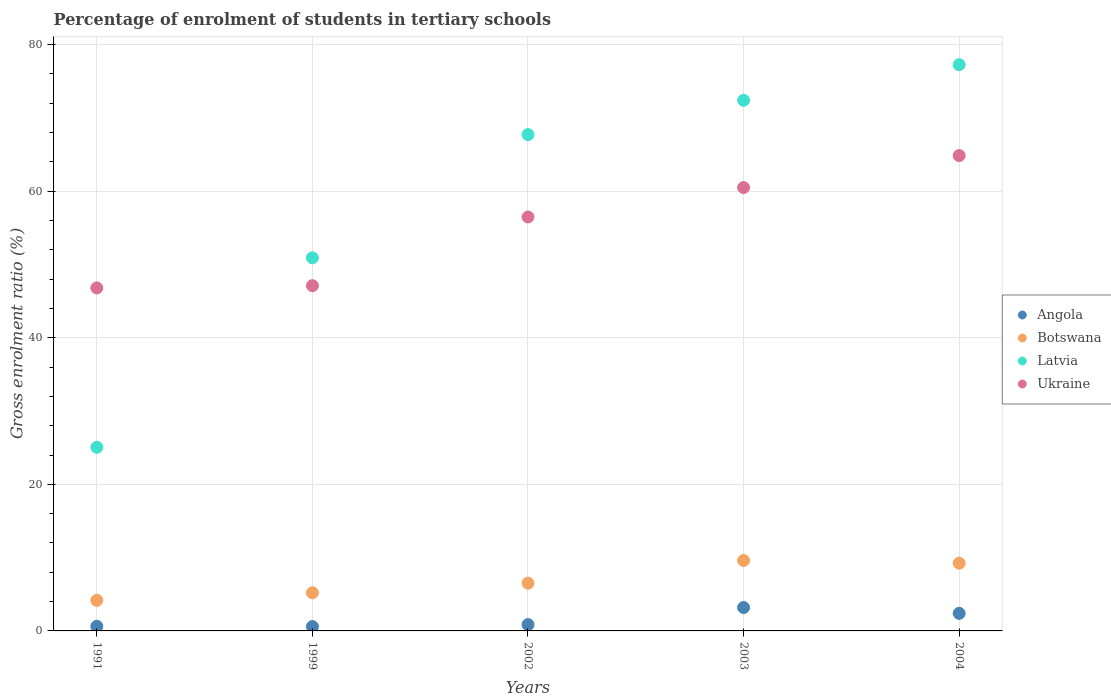What is the percentage of students enrolled in tertiary schools in Ukraine in 1991?
Make the answer very short. 46.8. Across all years, what is the maximum percentage of students enrolled in tertiary schools in Ukraine?
Make the answer very short. 64.86. Across all years, what is the minimum percentage of students enrolled in tertiary schools in Angola?
Keep it short and to the point. 0.6. In which year was the percentage of students enrolled in tertiary schools in Ukraine maximum?
Make the answer very short. 2004. In which year was the percentage of students enrolled in tertiary schools in Botswana minimum?
Keep it short and to the point. 1991. What is the total percentage of students enrolled in tertiary schools in Ukraine in the graph?
Offer a terse response. 275.73. What is the difference between the percentage of students enrolled in tertiary schools in Botswana in 2002 and that in 2004?
Make the answer very short. -2.72. What is the difference between the percentage of students enrolled in tertiary schools in Angola in 2004 and the percentage of students enrolled in tertiary schools in Latvia in 2002?
Offer a terse response. -65.32. What is the average percentage of students enrolled in tertiary schools in Ukraine per year?
Ensure brevity in your answer.  55.15. In the year 2004, what is the difference between the percentage of students enrolled in tertiary schools in Ukraine and percentage of students enrolled in tertiary schools in Angola?
Your response must be concise. 62.46. What is the ratio of the percentage of students enrolled in tertiary schools in Ukraine in 1991 to that in 2004?
Your response must be concise. 0.72. Is the percentage of students enrolled in tertiary schools in Angola in 1991 less than that in 2003?
Your answer should be compact. Yes. Is the difference between the percentage of students enrolled in tertiary schools in Ukraine in 1991 and 2004 greater than the difference between the percentage of students enrolled in tertiary schools in Angola in 1991 and 2004?
Your answer should be compact. No. What is the difference between the highest and the second highest percentage of students enrolled in tertiary schools in Angola?
Your answer should be very brief. 0.8. What is the difference between the highest and the lowest percentage of students enrolled in tertiary schools in Angola?
Make the answer very short. 2.6. Is it the case that in every year, the sum of the percentage of students enrolled in tertiary schools in Ukraine and percentage of students enrolled in tertiary schools in Latvia  is greater than the percentage of students enrolled in tertiary schools in Angola?
Provide a short and direct response. Yes. Does the percentage of students enrolled in tertiary schools in Botswana monotonically increase over the years?
Offer a terse response. No. Is the percentage of students enrolled in tertiary schools in Angola strictly greater than the percentage of students enrolled in tertiary schools in Latvia over the years?
Your answer should be compact. No. Is the percentage of students enrolled in tertiary schools in Ukraine strictly less than the percentage of students enrolled in tertiary schools in Angola over the years?
Provide a succinct answer. No. How many dotlines are there?
Your answer should be compact. 4. Are the values on the major ticks of Y-axis written in scientific E-notation?
Your response must be concise. No. Does the graph contain any zero values?
Offer a terse response. No. Does the graph contain grids?
Your answer should be very brief. Yes. Where does the legend appear in the graph?
Provide a succinct answer. Center right. What is the title of the graph?
Offer a terse response. Percentage of enrolment of students in tertiary schools. Does "Sub-Saharan Africa (all income levels)" appear as one of the legend labels in the graph?
Provide a short and direct response. No. What is the Gross enrolment ratio (%) of Angola in 1991?
Ensure brevity in your answer.  0.63. What is the Gross enrolment ratio (%) of Botswana in 1991?
Give a very brief answer. 4.17. What is the Gross enrolment ratio (%) in Latvia in 1991?
Offer a very short reply. 25.06. What is the Gross enrolment ratio (%) in Ukraine in 1991?
Ensure brevity in your answer.  46.8. What is the Gross enrolment ratio (%) of Angola in 1999?
Provide a short and direct response. 0.6. What is the Gross enrolment ratio (%) in Botswana in 1999?
Offer a very short reply. 5.21. What is the Gross enrolment ratio (%) in Latvia in 1999?
Give a very brief answer. 50.91. What is the Gross enrolment ratio (%) of Ukraine in 1999?
Offer a very short reply. 47.1. What is the Gross enrolment ratio (%) in Angola in 2002?
Your answer should be compact. 0.86. What is the Gross enrolment ratio (%) of Botswana in 2002?
Make the answer very short. 6.52. What is the Gross enrolment ratio (%) in Latvia in 2002?
Make the answer very short. 67.72. What is the Gross enrolment ratio (%) of Ukraine in 2002?
Provide a succinct answer. 56.48. What is the Gross enrolment ratio (%) of Angola in 2003?
Your answer should be very brief. 3.19. What is the Gross enrolment ratio (%) of Botswana in 2003?
Your answer should be compact. 9.61. What is the Gross enrolment ratio (%) of Latvia in 2003?
Ensure brevity in your answer.  72.4. What is the Gross enrolment ratio (%) of Ukraine in 2003?
Give a very brief answer. 60.49. What is the Gross enrolment ratio (%) of Angola in 2004?
Your answer should be very brief. 2.4. What is the Gross enrolment ratio (%) in Botswana in 2004?
Keep it short and to the point. 9.24. What is the Gross enrolment ratio (%) of Latvia in 2004?
Offer a terse response. 77.26. What is the Gross enrolment ratio (%) in Ukraine in 2004?
Provide a short and direct response. 64.86. Across all years, what is the maximum Gross enrolment ratio (%) in Angola?
Your response must be concise. 3.19. Across all years, what is the maximum Gross enrolment ratio (%) in Botswana?
Provide a short and direct response. 9.61. Across all years, what is the maximum Gross enrolment ratio (%) in Latvia?
Offer a terse response. 77.26. Across all years, what is the maximum Gross enrolment ratio (%) of Ukraine?
Provide a succinct answer. 64.86. Across all years, what is the minimum Gross enrolment ratio (%) of Angola?
Ensure brevity in your answer.  0.6. Across all years, what is the minimum Gross enrolment ratio (%) of Botswana?
Ensure brevity in your answer.  4.17. Across all years, what is the minimum Gross enrolment ratio (%) in Latvia?
Your answer should be compact. 25.06. Across all years, what is the minimum Gross enrolment ratio (%) of Ukraine?
Give a very brief answer. 46.8. What is the total Gross enrolment ratio (%) of Angola in the graph?
Your response must be concise. 7.67. What is the total Gross enrolment ratio (%) of Botswana in the graph?
Offer a very short reply. 34.75. What is the total Gross enrolment ratio (%) of Latvia in the graph?
Provide a short and direct response. 293.35. What is the total Gross enrolment ratio (%) in Ukraine in the graph?
Offer a very short reply. 275.73. What is the difference between the Gross enrolment ratio (%) in Angola in 1991 and that in 1999?
Ensure brevity in your answer.  0.03. What is the difference between the Gross enrolment ratio (%) of Botswana in 1991 and that in 1999?
Make the answer very short. -1.03. What is the difference between the Gross enrolment ratio (%) of Latvia in 1991 and that in 1999?
Keep it short and to the point. -25.85. What is the difference between the Gross enrolment ratio (%) in Ukraine in 1991 and that in 1999?
Your response must be concise. -0.3. What is the difference between the Gross enrolment ratio (%) in Angola in 1991 and that in 2002?
Give a very brief answer. -0.24. What is the difference between the Gross enrolment ratio (%) of Botswana in 1991 and that in 2002?
Your answer should be very brief. -2.35. What is the difference between the Gross enrolment ratio (%) of Latvia in 1991 and that in 2002?
Your answer should be very brief. -42.66. What is the difference between the Gross enrolment ratio (%) in Ukraine in 1991 and that in 2002?
Give a very brief answer. -9.68. What is the difference between the Gross enrolment ratio (%) of Angola in 1991 and that in 2003?
Your answer should be compact. -2.57. What is the difference between the Gross enrolment ratio (%) of Botswana in 1991 and that in 2003?
Provide a succinct answer. -5.44. What is the difference between the Gross enrolment ratio (%) of Latvia in 1991 and that in 2003?
Provide a short and direct response. -47.34. What is the difference between the Gross enrolment ratio (%) in Ukraine in 1991 and that in 2003?
Make the answer very short. -13.69. What is the difference between the Gross enrolment ratio (%) in Angola in 1991 and that in 2004?
Provide a succinct answer. -1.77. What is the difference between the Gross enrolment ratio (%) in Botswana in 1991 and that in 2004?
Make the answer very short. -5.07. What is the difference between the Gross enrolment ratio (%) of Latvia in 1991 and that in 2004?
Offer a terse response. -52.2. What is the difference between the Gross enrolment ratio (%) of Ukraine in 1991 and that in 2004?
Keep it short and to the point. -18.06. What is the difference between the Gross enrolment ratio (%) in Angola in 1999 and that in 2002?
Your answer should be compact. -0.27. What is the difference between the Gross enrolment ratio (%) in Botswana in 1999 and that in 2002?
Your answer should be compact. -1.31. What is the difference between the Gross enrolment ratio (%) in Latvia in 1999 and that in 2002?
Give a very brief answer. -16.81. What is the difference between the Gross enrolment ratio (%) in Ukraine in 1999 and that in 2002?
Provide a succinct answer. -9.38. What is the difference between the Gross enrolment ratio (%) in Angola in 1999 and that in 2003?
Your answer should be very brief. -2.6. What is the difference between the Gross enrolment ratio (%) in Botswana in 1999 and that in 2003?
Keep it short and to the point. -4.41. What is the difference between the Gross enrolment ratio (%) of Latvia in 1999 and that in 2003?
Make the answer very short. -21.49. What is the difference between the Gross enrolment ratio (%) of Ukraine in 1999 and that in 2003?
Your answer should be very brief. -13.39. What is the difference between the Gross enrolment ratio (%) of Angola in 1999 and that in 2004?
Provide a short and direct response. -1.8. What is the difference between the Gross enrolment ratio (%) of Botswana in 1999 and that in 2004?
Keep it short and to the point. -4.04. What is the difference between the Gross enrolment ratio (%) of Latvia in 1999 and that in 2004?
Give a very brief answer. -26.35. What is the difference between the Gross enrolment ratio (%) of Ukraine in 1999 and that in 2004?
Ensure brevity in your answer.  -17.75. What is the difference between the Gross enrolment ratio (%) in Angola in 2002 and that in 2003?
Your answer should be compact. -2.33. What is the difference between the Gross enrolment ratio (%) in Botswana in 2002 and that in 2003?
Your answer should be compact. -3.09. What is the difference between the Gross enrolment ratio (%) of Latvia in 2002 and that in 2003?
Keep it short and to the point. -4.68. What is the difference between the Gross enrolment ratio (%) in Ukraine in 2002 and that in 2003?
Provide a succinct answer. -4.01. What is the difference between the Gross enrolment ratio (%) in Angola in 2002 and that in 2004?
Your answer should be compact. -1.53. What is the difference between the Gross enrolment ratio (%) in Botswana in 2002 and that in 2004?
Offer a very short reply. -2.72. What is the difference between the Gross enrolment ratio (%) of Latvia in 2002 and that in 2004?
Ensure brevity in your answer.  -9.54. What is the difference between the Gross enrolment ratio (%) of Ukraine in 2002 and that in 2004?
Provide a short and direct response. -8.38. What is the difference between the Gross enrolment ratio (%) in Angola in 2003 and that in 2004?
Offer a terse response. 0.8. What is the difference between the Gross enrolment ratio (%) of Botswana in 2003 and that in 2004?
Make the answer very short. 0.37. What is the difference between the Gross enrolment ratio (%) of Latvia in 2003 and that in 2004?
Give a very brief answer. -4.86. What is the difference between the Gross enrolment ratio (%) of Ukraine in 2003 and that in 2004?
Your response must be concise. -4.36. What is the difference between the Gross enrolment ratio (%) of Angola in 1991 and the Gross enrolment ratio (%) of Botswana in 1999?
Keep it short and to the point. -4.58. What is the difference between the Gross enrolment ratio (%) of Angola in 1991 and the Gross enrolment ratio (%) of Latvia in 1999?
Make the answer very short. -50.28. What is the difference between the Gross enrolment ratio (%) in Angola in 1991 and the Gross enrolment ratio (%) in Ukraine in 1999?
Give a very brief answer. -46.48. What is the difference between the Gross enrolment ratio (%) in Botswana in 1991 and the Gross enrolment ratio (%) in Latvia in 1999?
Your response must be concise. -46.74. What is the difference between the Gross enrolment ratio (%) in Botswana in 1991 and the Gross enrolment ratio (%) in Ukraine in 1999?
Provide a succinct answer. -42.93. What is the difference between the Gross enrolment ratio (%) in Latvia in 1991 and the Gross enrolment ratio (%) in Ukraine in 1999?
Your response must be concise. -22.05. What is the difference between the Gross enrolment ratio (%) of Angola in 1991 and the Gross enrolment ratio (%) of Botswana in 2002?
Keep it short and to the point. -5.89. What is the difference between the Gross enrolment ratio (%) of Angola in 1991 and the Gross enrolment ratio (%) of Latvia in 2002?
Make the answer very short. -67.1. What is the difference between the Gross enrolment ratio (%) in Angola in 1991 and the Gross enrolment ratio (%) in Ukraine in 2002?
Give a very brief answer. -55.85. What is the difference between the Gross enrolment ratio (%) of Botswana in 1991 and the Gross enrolment ratio (%) of Latvia in 2002?
Offer a terse response. -63.55. What is the difference between the Gross enrolment ratio (%) of Botswana in 1991 and the Gross enrolment ratio (%) of Ukraine in 2002?
Keep it short and to the point. -52.31. What is the difference between the Gross enrolment ratio (%) in Latvia in 1991 and the Gross enrolment ratio (%) in Ukraine in 2002?
Give a very brief answer. -31.42. What is the difference between the Gross enrolment ratio (%) of Angola in 1991 and the Gross enrolment ratio (%) of Botswana in 2003?
Offer a terse response. -8.99. What is the difference between the Gross enrolment ratio (%) of Angola in 1991 and the Gross enrolment ratio (%) of Latvia in 2003?
Ensure brevity in your answer.  -71.78. What is the difference between the Gross enrolment ratio (%) of Angola in 1991 and the Gross enrolment ratio (%) of Ukraine in 2003?
Keep it short and to the point. -59.87. What is the difference between the Gross enrolment ratio (%) of Botswana in 1991 and the Gross enrolment ratio (%) of Latvia in 2003?
Your response must be concise. -68.23. What is the difference between the Gross enrolment ratio (%) of Botswana in 1991 and the Gross enrolment ratio (%) of Ukraine in 2003?
Offer a terse response. -56.32. What is the difference between the Gross enrolment ratio (%) in Latvia in 1991 and the Gross enrolment ratio (%) in Ukraine in 2003?
Provide a short and direct response. -35.44. What is the difference between the Gross enrolment ratio (%) in Angola in 1991 and the Gross enrolment ratio (%) in Botswana in 2004?
Give a very brief answer. -8.62. What is the difference between the Gross enrolment ratio (%) in Angola in 1991 and the Gross enrolment ratio (%) in Latvia in 2004?
Provide a short and direct response. -76.63. What is the difference between the Gross enrolment ratio (%) in Angola in 1991 and the Gross enrolment ratio (%) in Ukraine in 2004?
Keep it short and to the point. -64.23. What is the difference between the Gross enrolment ratio (%) of Botswana in 1991 and the Gross enrolment ratio (%) of Latvia in 2004?
Your answer should be very brief. -73.09. What is the difference between the Gross enrolment ratio (%) in Botswana in 1991 and the Gross enrolment ratio (%) in Ukraine in 2004?
Provide a short and direct response. -60.69. What is the difference between the Gross enrolment ratio (%) of Latvia in 1991 and the Gross enrolment ratio (%) of Ukraine in 2004?
Provide a short and direct response. -39.8. What is the difference between the Gross enrolment ratio (%) in Angola in 1999 and the Gross enrolment ratio (%) in Botswana in 2002?
Offer a terse response. -5.92. What is the difference between the Gross enrolment ratio (%) of Angola in 1999 and the Gross enrolment ratio (%) of Latvia in 2002?
Give a very brief answer. -67.13. What is the difference between the Gross enrolment ratio (%) of Angola in 1999 and the Gross enrolment ratio (%) of Ukraine in 2002?
Provide a short and direct response. -55.88. What is the difference between the Gross enrolment ratio (%) in Botswana in 1999 and the Gross enrolment ratio (%) in Latvia in 2002?
Offer a terse response. -62.52. What is the difference between the Gross enrolment ratio (%) of Botswana in 1999 and the Gross enrolment ratio (%) of Ukraine in 2002?
Make the answer very short. -51.27. What is the difference between the Gross enrolment ratio (%) in Latvia in 1999 and the Gross enrolment ratio (%) in Ukraine in 2002?
Your response must be concise. -5.57. What is the difference between the Gross enrolment ratio (%) of Angola in 1999 and the Gross enrolment ratio (%) of Botswana in 2003?
Your response must be concise. -9.02. What is the difference between the Gross enrolment ratio (%) of Angola in 1999 and the Gross enrolment ratio (%) of Latvia in 2003?
Provide a succinct answer. -71.81. What is the difference between the Gross enrolment ratio (%) in Angola in 1999 and the Gross enrolment ratio (%) in Ukraine in 2003?
Give a very brief answer. -59.9. What is the difference between the Gross enrolment ratio (%) of Botswana in 1999 and the Gross enrolment ratio (%) of Latvia in 2003?
Your answer should be compact. -67.2. What is the difference between the Gross enrolment ratio (%) in Botswana in 1999 and the Gross enrolment ratio (%) in Ukraine in 2003?
Offer a very short reply. -55.29. What is the difference between the Gross enrolment ratio (%) in Latvia in 1999 and the Gross enrolment ratio (%) in Ukraine in 2003?
Your answer should be very brief. -9.59. What is the difference between the Gross enrolment ratio (%) of Angola in 1999 and the Gross enrolment ratio (%) of Botswana in 2004?
Give a very brief answer. -8.65. What is the difference between the Gross enrolment ratio (%) of Angola in 1999 and the Gross enrolment ratio (%) of Latvia in 2004?
Offer a terse response. -76.66. What is the difference between the Gross enrolment ratio (%) in Angola in 1999 and the Gross enrolment ratio (%) in Ukraine in 2004?
Your answer should be compact. -64.26. What is the difference between the Gross enrolment ratio (%) in Botswana in 1999 and the Gross enrolment ratio (%) in Latvia in 2004?
Offer a terse response. -72.05. What is the difference between the Gross enrolment ratio (%) in Botswana in 1999 and the Gross enrolment ratio (%) in Ukraine in 2004?
Ensure brevity in your answer.  -59.65. What is the difference between the Gross enrolment ratio (%) of Latvia in 1999 and the Gross enrolment ratio (%) of Ukraine in 2004?
Keep it short and to the point. -13.95. What is the difference between the Gross enrolment ratio (%) of Angola in 2002 and the Gross enrolment ratio (%) of Botswana in 2003?
Give a very brief answer. -8.75. What is the difference between the Gross enrolment ratio (%) in Angola in 2002 and the Gross enrolment ratio (%) in Latvia in 2003?
Make the answer very short. -71.54. What is the difference between the Gross enrolment ratio (%) of Angola in 2002 and the Gross enrolment ratio (%) of Ukraine in 2003?
Ensure brevity in your answer.  -59.63. What is the difference between the Gross enrolment ratio (%) in Botswana in 2002 and the Gross enrolment ratio (%) in Latvia in 2003?
Provide a succinct answer. -65.88. What is the difference between the Gross enrolment ratio (%) in Botswana in 2002 and the Gross enrolment ratio (%) in Ukraine in 2003?
Provide a succinct answer. -53.97. What is the difference between the Gross enrolment ratio (%) in Latvia in 2002 and the Gross enrolment ratio (%) in Ukraine in 2003?
Give a very brief answer. 7.23. What is the difference between the Gross enrolment ratio (%) of Angola in 2002 and the Gross enrolment ratio (%) of Botswana in 2004?
Offer a terse response. -8.38. What is the difference between the Gross enrolment ratio (%) of Angola in 2002 and the Gross enrolment ratio (%) of Latvia in 2004?
Provide a short and direct response. -76.4. What is the difference between the Gross enrolment ratio (%) in Angola in 2002 and the Gross enrolment ratio (%) in Ukraine in 2004?
Your answer should be compact. -63.99. What is the difference between the Gross enrolment ratio (%) of Botswana in 2002 and the Gross enrolment ratio (%) of Latvia in 2004?
Your answer should be compact. -70.74. What is the difference between the Gross enrolment ratio (%) of Botswana in 2002 and the Gross enrolment ratio (%) of Ukraine in 2004?
Offer a terse response. -58.34. What is the difference between the Gross enrolment ratio (%) of Latvia in 2002 and the Gross enrolment ratio (%) of Ukraine in 2004?
Your answer should be very brief. 2.86. What is the difference between the Gross enrolment ratio (%) in Angola in 2003 and the Gross enrolment ratio (%) in Botswana in 2004?
Provide a succinct answer. -6.05. What is the difference between the Gross enrolment ratio (%) in Angola in 2003 and the Gross enrolment ratio (%) in Latvia in 2004?
Keep it short and to the point. -74.07. What is the difference between the Gross enrolment ratio (%) of Angola in 2003 and the Gross enrolment ratio (%) of Ukraine in 2004?
Offer a very short reply. -61.66. What is the difference between the Gross enrolment ratio (%) in Botswana in 2003 and the Gross enrolment ratio (%) in Latvia in 2004?
Provide a succinct answer. -67.65. What is the difference between the Gross enrolment ratio (%) in Botswana in 2003 and the Gross enrolment ratio (%) in Ukraine in 2004?
Ensure brevity in your answer.  -55.24. What is the difference between the Gross enrolment ratio (%) in Latvia in 2003 and the Gross enrolment ratio (%) in Ukraine in 2004?
Your answer should be compact. 7.55. What is the average Gross enrolment ratio (%) in Angola per year?
Provide a succinct answer. 1.53. What is the average Gross enrolment ratio (%) of Botswana per year?
Offer a very short reply. 6.95. What is the average Gross enrolment ratio (%) in Latvia per year?
Keep it short and to the point. 58.67. What is the average Gross enrolment ratio (%) in Ukraine per year?
Ensure brevity in your answer.  55.15. In the year 1991, what is the difference between the Gross enrolment ratio (%) of Angola and Gross enrolment ratio (%) of Botswana?
Provide a short and direct response. -3.55. In the year 1991, what is the difference between the Gross enrolment ratio (%) in Angola and Gross enrolment ratio (%) in Latvia?
Your answer should be compact. -24.43. In the year 1991, what is the difference between the Gross enrolment ratio (%) in Angola and Gross enrolment ratio (%) in Ukraine?
Make the answer very short. -46.18. In the year 1991, what is the difference between the Gross enrolment ratio (%) in Botswana and Gross enrolment ratio (%) in Latvia?
Your answer should be very brief. -20.89. In the year 1991, what is the difference between the Gross enrolment ratio (%) in Botswana and Gross enrolment ratio (%) in Ukraine?
Give a very brief answer. -42.63. In the year 1991, what is the difference between the Gross enrolment ratio (%) in Latvia and Gross enrolment ratio (%) in Ukraine?
Make the answer very short. -21.74. In the year 1999, what is the difference between the Gross enrolment ratio (%) of Angola and Gross enrolment ratio (%) of Botswana?
Offer a very short reply. -4.61. In the year 1999, what is the difference between the Gross enrolment ratio (%) in Angola and Gross enrolment ratio (%) in Latvia?
Offer a terse response. -50.31. In the year 1999, what is the difference between the Gross enrolment ratio (%) of Angola and Gross enrolment ratio (%) of Ukraine?
Ensure brevity in your answer.  -46.51. In the year 1999, what is the difference between the Gross enrolment ratio (%) in Botswana and Gross enrolment ratio (%) in Latvia?
Make the answer very short. -45.7. In the year 1999, what is the difference between the Gross enrolment ratio (%) in Botswana and Gross enrolment ratio (%) in Ukraine?
Provide a succinct answer. -41.9. In the year 1999, what is the difference between the Gross enrolment ratio (%) in Latvia and Gross enrolment ratio (%) in Ukraine?
Provide a succinct answer. 3.8. In the year 2002, what is the difference between the Gross enrolment ratio (%) in Angola and Gross enrolment ratio (%) in Botswana?
Give a very brief answer. -5.65. In the year 2002, what is the difference between the Gross enrolment ratio (%) of Angola and Gross enrolment ratio (%) of Latvia?
Your answer should be very brief. -66.86. In the year 2002, what is the difference between the Gross enrolment ratio (%) of Angola and Gross enrolment ratio (%) of Ukraine?
Provide a succinct answer. -55.62. In the year 2002, what is the difference between the Gross enrolment ratio (%) of Botswana and Gross enrolment ratio (%) of Latvia?
Your answer should be very brief. -61.2. In the year 2002, what is the difference between the Gross enrolment ratio (%) of Botswana and Gross enrolment ratio (%) of Ukraine?
Make the answer very short. -49.96. In the year 2002, what is the difference between the Gross enrolment ratio (%) of Latvia and Gross enrolment ratio (%) of Ukraine?
Keep it short and to the point. 11.24. In the year 2003, what is the difference between the Gross enrolment ratio (%) of Angola and Gross enrolment ratio (%) of Botswana?
Ensure brevity in your answer.  -6.42. In the year 2003, what is the difference between the Gross enrolment ratio (%) of Angola and Gross enrolment ratio (%) of Latvia?
Ensure brevity in your answer.  -69.21. In the year 2003, what is the difference between the Gross enrolment ratio (%) of Angola and Gross enrolment ratio (%) of Ukraine?
Offer a very short reply. -57.3. In the year 2003, what is the difference between the Gross enrolment ratio (%) in Botswana and Gross enrolment ratio (%) in Latvia?
Offer a very short reply. -62.79. In the year 2003, what is the difference between the Gross enrolment ratio (%) of Botswana and Gross enrolment ratio (%) of Ukraine?
Provide a short and direct response. -50.88. In the year 2003, what is the difference between the Gross enrolment ratio (%) in Latvia and Gross enrolment ratio (%) in Ukraine?
Your answer should be very brief. 11.91. In the year 2004, what is the difference between the Gross enrolment ratio (%) of Angola and Gross enrolment ratio (%) of Botswana?
Make the answer very short. -6.84. In the year 2004, what is the difference between the Gross enrolment ratio (%) of Angola and Gross enrolment ratio (%) of Latvia?
Give a very brief answer. -74.86. In the year 2004, what is the difference between the Gross enrolment ratio (%) in Angola and Gross enrolment ratio (%) in Ukraine?
Give a very brief answer. -62.46. In the year 2004, what is the difference between the Gross enrolment ratio (%) of Botswana and Gross enrolment ratio (%) of Latvia?
Ensure brevity in your answer.  -68.02. In the year 2004, what is the difference between the Gross enrolment ratio (%) in Botswana and Gross enrolment ratio (%) in Ukraine?
Give a very brief answer. -55.61. In the year 2004, what is the difference between the Gross enrolment ratio (%) in Latvia and Gross enrolment ratio (%) in Ukraine?
Ensure brevity in your answer.  12.4. What is the ratio of the Gross enrolment ratio (%) of Angola in 1991 to that in 1999?
Provide a succinct answer. 1.05. What is the ratio of the Gross enrolment ratio (%) of Botswana in 1991 to that in 1999?
Your response must be concise. 0.8. What is the ratio of the Gross enrolment ratio (%) in Latvia in 1991 to that in 1999?
Make the answer very short. 0.49. What is the ratio of the Gross enrolment ratio (%) in Ukraine in 1991 to that in 1999?
Your response must be concise. 0.99. What is the ratio of the Gross enrolment ratio (%) in Angola in 1991 to that in 2002?
Your response must be concise. 0.72. What is the ratio of the Gross enrolment ratio (%) in Botswana in 1991 to that in 2002?
Offer a very short reply. 0.64. What is the ratio of the Gross enrolment ratio (%) in Latvia in 1991 to that in 2002?
Keep it short and to the point. 0.37. What is the ratio of the Gross enrolment ratio (%) of Ukraine in 1991 to that in 2002?
Provide a short and direct response. 0.83. What is the ratio of the Gross enrolment ratio (%) of Angola in 1991 to that in 2003?
Offer a very short reply. 0.2. What is the ratio of the Gross enrolment ratio (%) of Botswana in 1991 to that in 2003?
Your answer should be very brief. 0.43. What is the ratio of the Gross enrolment ratio (%) in Latvia in 1991 to that in 2003?
Make the answer very short. 0.35. What is the ratio of the Gross enrolment ratio (%) of Ukraine in 1991 to that in 2003?
Your answer should be very brief. 0.77. What is the ratio of the Gross enrolment ratio (%) in Angola in 1991 to that in 2004?
Provide a short and direct response. 0.26. What is the ratio of the Gross enrolment ratio (%) in Botswana in 1991 to that in 2004?
Provide a succinct answer. 0.45. What is the ratio of the Gross enrolment ratio (%) in Latvia in 1991 to that in 2004?
Your response must be concise. 0.32. What is the ratio of the Gross enrolment ratio (%) of Ukraine in 1991 to that in 2004?
Give a very brief answer. 0.72. What is the ratio of the Gross enrolment ratio (%) of Angola in 1999 to that in 2002?
Give a very brief answer. 0.69. What is the ratio of the Gross enrolment ratio (%) in Botswana in 1999 to that in 2002?
Keep it short and to the point. 0.8. What is the ratio of the Gross enrolment ratio (%) of Latvia in 1999 to that in 2002?
Give a very brief answer. 0.75. What is the ratio of the Gross enrolment ratio (%) in Ukraine in 1999 to that in 2002?
Your answer should be compact. 0.83. What is the ratio of the Gross enrolment ratio (%) of Angola in 1999 to that in 2003?
Provide a succinct answer. 0.19. What is the ratio of the Gross enrolment ratio (%) in Botswana in 1999 to that in 2003?
Provide a short and direct response. 0.54. What is the ratio of the Gross enrolment ratio (%) of Latvia in 1999 to that in 2003?
Your answer should be very brief. 0.7. What is the ratio of the Gross enrolment ratio (%) in Ukraine in 1999 to that in 2003?
Provide a short and direct response. 0.78. What is the ratio of the Gross enrolment ratio (%) of Angola in 1999 to that in 2004?
Offer a very short reply. 0.25. What is the ratio of the Gross enrolment ratio (%) of Botswana in 1999 to that in 2004?
Your answer should be very brief. 0.56. What is the ratio of the Gross enrolment ratio (%) of Latvia in 1999 to that in 2004?
Offer a terse response. 0.66. What is the ratio of the Gross enrolment ratio (%) of Ukraine in 1999 to that in 2004?
Offer a very short reply. 0.73. What is the ratio of the Gross enrolment ratio (%) in Angola in 2002 to that in 2003?
Your answer should be very brief. 0.27. What is the ratio of the Gross enrolment ratio (%) in Botswana in 2002 to that in 2003?
Make the answer very short. 0.68. What is the ratio of the Gross enrolment ratio (%) in Latvia in 2002 to that in 2003?
Make the answer very short. 0.94. What is the ratio of the Gross enrolment ratio (%) of Ukraine in 2002 to that in 2003?
Offer a terse response. 0.93. What is the ratio of the Gross enrolment ratio (%) of Angola in 2002 to that in 2004?
Offer a terse response. 0.36. What is the ratio of the Gross enrolment ratio (%) in Botswana in 2002 to that in 2004?
Make the answer very short. 0.71. What is the ratio of the Gross enrolment ratio (%) of Latvia in 2002 to that in 2004?
Provide a succinct answer. 0.88. What is the ratio of the Gross enrolment ratio (%) of Ukraine in 2002 to that in 2004?
Ensure brevity in your answer.  0.87. What is the ratio of the Gross enrolment ratio (%) in Angola in 2003 to that in 2004?
Provide a short and direct response. 1.33. What is the ratio of the Gross enrolment ratio (%) of Botswana in 2003 to that in 2004?
Offer a terse response. 1.04. What is the ratio of the Gross enrolment ratio (%) of Latvia in 2003 to that in 2004?
Provide a short and direct response. 0.94. What is the ratio of the Gross enrolment ratio (%) in Ukraine in 2003 to that in 2004?
Offer a very short reply. 0.93. What is the difference between the highest and the second highest Gross enrolment ratio (%) of Angola?
Your response must be concise. 0.8. What is the difference between the highest and the second highest Gross enrolment ratio (%) of Botswana?
Provide a short and direct response. 0.37. What is the difference between the highest and the second highest Gross enrolment ratio (%) of Latvia?
Provide a succinct answer. 4.86. What is the difference between the highest and the second highest Gross enrolment ratio (%) in Ukraine?
Your answer should be very brief. 4.36. What is the difference between the highest and the lowest Gross enrolment ratio (%) in Angola?
Your answer should be compact. 2.6. What is the difference between the highest and the lowest Gross enrolment ratio (%) of Botswana?
Ensure brevity in your answer.  5.44. What is the difference between the highest and the lowest Gross enrolment ratio (%) in Latvia?
Your answer should be compact. 52.2. What is the difference between the highest and the lowest Gross enrolment ratio (%) of Ukraine?
Your response must be concise. 18.06. 